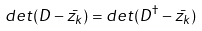Convert formula to latex. <formula><loc_0><loc_0><loc_500><loc_500>d e t ( D - \bar { z _ { k } } ) = d e t ( D ^ { \dagger } - \bar { z _ { k } } )</formula> 